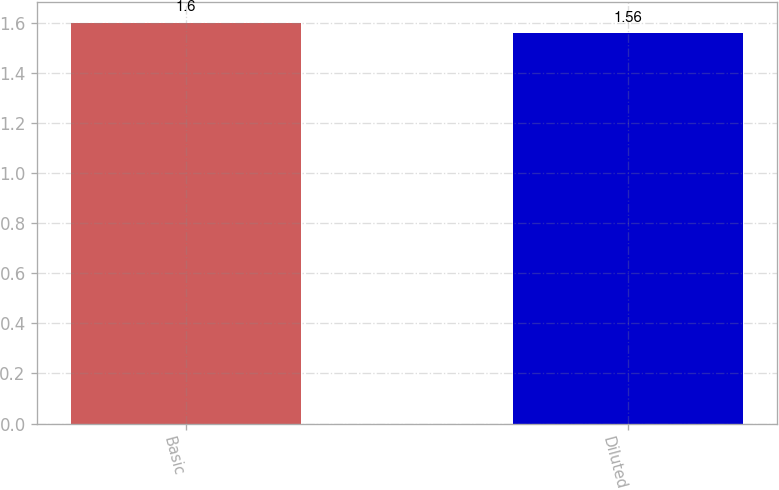<chart> <loc_0><loc_0><loc_500><loc_500><bar_chart><fcel>Basic<fcel>Diluted<nl><fcel>1.6<fcel>1.56<nl></chart> 